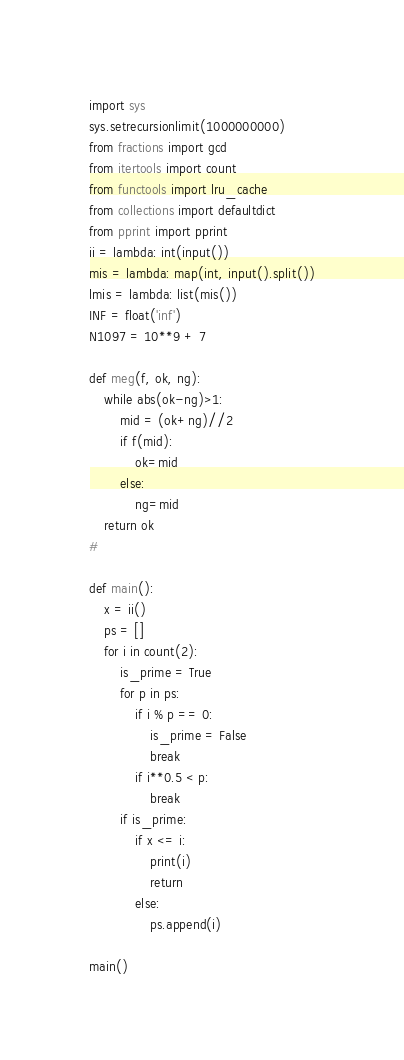Convert code to text. <code><loc_0><loc_0><loc_500><loc_500><_Python_>import sys
sys.setrecursionlimit(1000000000)
from fractions import gcd
from itertools import count
from functools import lru_cache
from collections import defaultdict
from pprint import pprint
ii = lambda: int(input())
mis = lambda: map(int, input().split())
lmis = lambda: list(mis())
INF = float('inf')
N1097 = 10**9 + 7

def meg(f, ok, ng):
    while abs(ok-ng)>1:
        mid = (ok+ng)//2
        if f(mid):
            ok=mid
        else:
            ng=mid
    return ok
#

def main():
    x = ii()
    ps = []
    for i in count(2):
        is_prime = True
        for p in ps:
            if i % p == 0:
                is_prime = False
                break
            if i**0.5 < p:
                break 
        if is_prime:
            if x <= i:
                print(i)
                return
            else:
                ps.append(i)

main()
</code> 